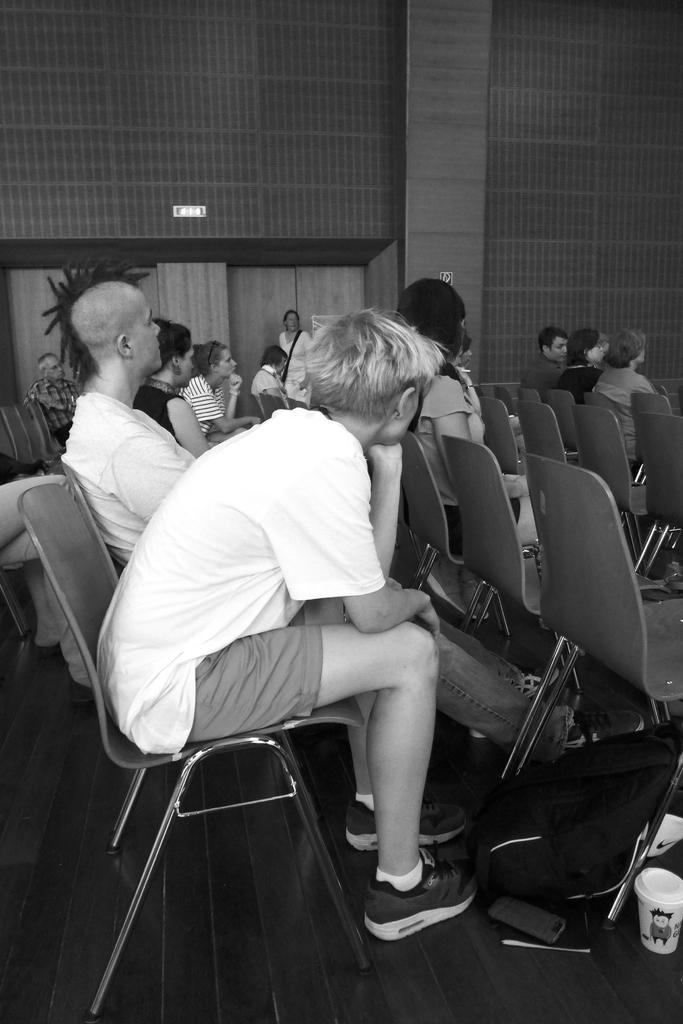How would you summarize this image in a sentence or two? This is a black and white image and here we can see people sitting on the chairs and in the background, there is a plant and we can see a board on the wall. At the bottom, there is a bag, mobile and some other objects on the floor. 